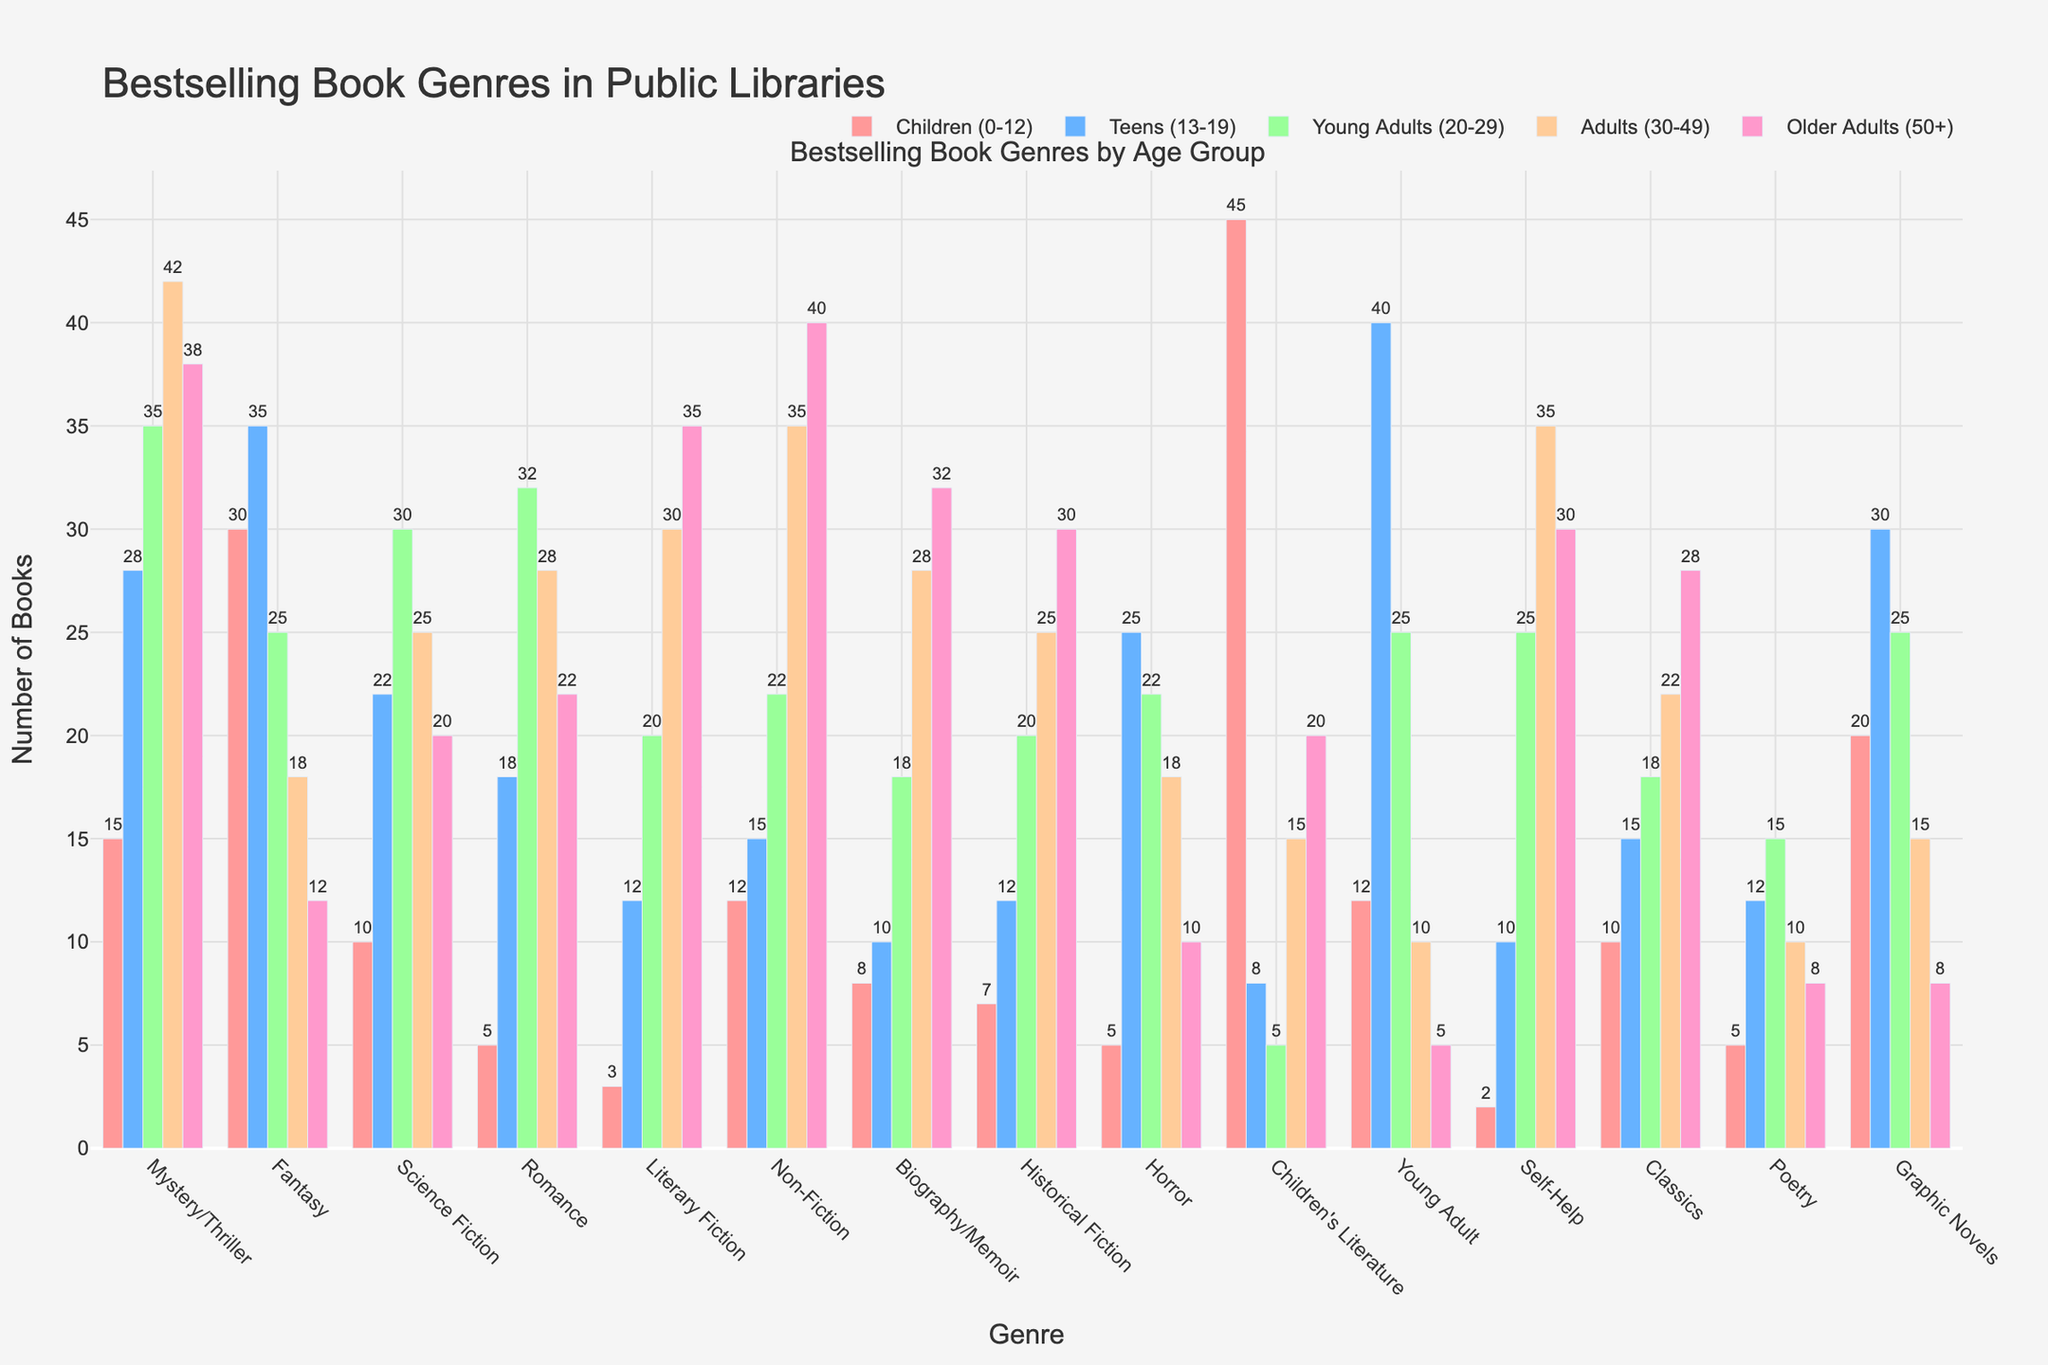Which genre is the most popular among children (0-12)? From the figure, the highest bar for the Children (0-12) group is "Children's Literature" with a value of 45, indicating it's the most popular genre among children.
Answer: Children's Literature How does the number of mystery/thriller books compare between young adults (20-29) and older adults (50+)? Comparing the height of the bars for Mystery/Thriller across the two age groups, Young Adults (20-29) have a count of 35, and Older Adults (50+) have a count of 38. Hence, Older Adults read slightly more Mystery/Thriller books.
Answer: Older Adults (50+) What's the total number of non-fiction books read by teens, young adults, and adults combined? Sum the number of Non-Fiction books across Teens (15), Young Adults (22), and Adults (35). The total is 15 + 22 + 35 = 72.
Answer: 72 In which age group is science fiction the least popular, and what is the count? By inspecting the length of the bars for Science Fiction, it's least popular among Children (0-12) with a count of 10.
Answer: Children (0-12) with 10 Compare the popularity of romance and historical fiction among adults (30-49). Looking at the heights of the bars, Romance has a count of 28 and Historical Fiction has a count of 25 among Adults (30-49). Thus, Romance is slightly more popular.
Answer: Romance What is the average number of fantasy books read across all age groups? Sum the number of Fantasy books across all age groups: 30 (Children) + 35 (Teens) + 25 (Young Adults) + 18 (Adults) + 12 (Older Adults). The total is 120. The average is 120 / 5 = 24.
Answer: 24 Which genre has the highest number of books read by teens (13-19)? Observe the highest bar in the Teens (13-19) group. "Young Adult" tops the chart with a count of 40.
Answer: Young Adult Are biographies/memoirs more popular among older adults (50+) or young adults (20-29)? Comparing the lengths of the bars, older adults (50+) read 32, whereas young adults (20-29) read 18 biographies/memoirs.
Answer: Older Adults (50+) What's the difference in the number of graphic novels read by teens (13-19) and children (0-12)? The figure shows that Teens read 30 Graphic Novels, and Children read 20. The difference is 30 - 20 = 10.
Answer: 10 How do non-fiction books compare visually to romance books across all age groups? The bars for Non-Fiction generally show higher counts than Romance across all age groups, with particularly notable differences among Adults (30-49) and Older Adults (50+).
Answer: Non-Fiction is generally more popular than Romance 